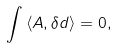<formula> <loc_0><loc_0><loc_500><loc_500>\int \left \langle A , \delta d \right \rangle = 0 ,</formula> 